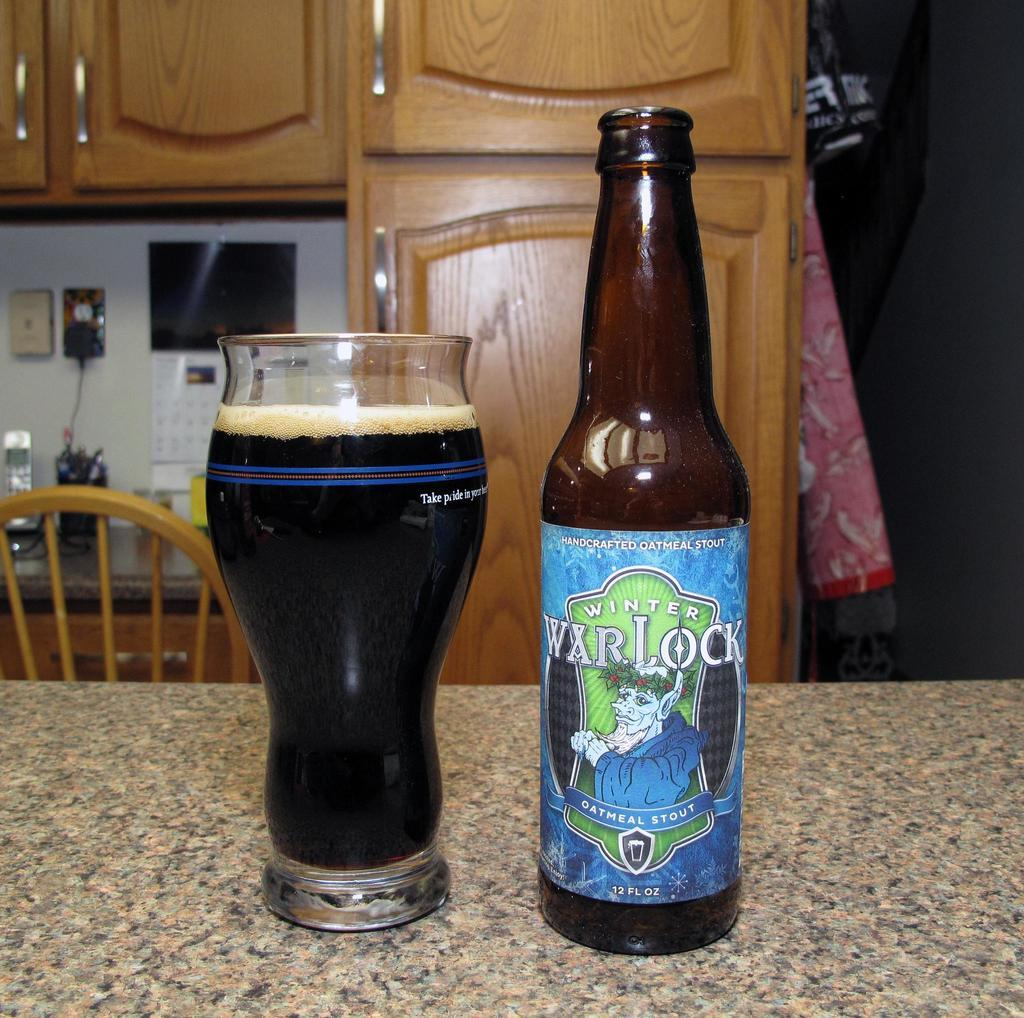<image>
Relay a brief, clear account of the picture shown. A glass and a beer bottle reading War Lock. 